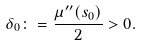<formula> <loc_0><loc_0><loc_500><loc_500>\delta _ { 0 } \colon = \frac { \mu ^ { \prime \prime } ( s _ { 0 } ) } { 2 } > 0 .</formula> 